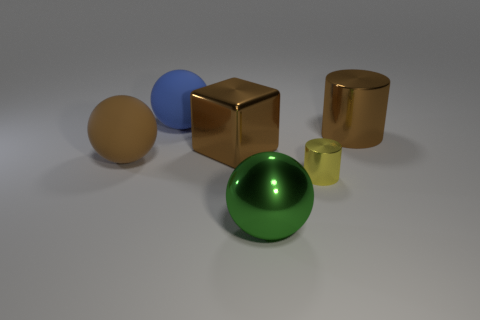Are there any other large shiny objects that have the same shape as the large green shiny thing?
Make the answer very short. No. Is the number of large matte things less than the number of big green rubber cylinders?
Provide a succinct answer. No. There is a shiny ball that is to the right of the large brown ball; what color is it?
Give a very brief answer. Green. There is a matte thing that is left of the big sphere behind the brown cube; what shape is it?
Your answer should be very brief. Sphere. Is the blue sphere made of the same material as the sphere that is to the right of the large block?
Offer a terse response. No. There is a metallic object that is the same color as the shiny cube; what is its shape?
Your answer should be very brief. Cylinder. What number of green metallic spheres have the same size as the blue matte thing?
Give a very brief answer. 1. Are there fewer large brown objects to the left of the blue matte object than big red rubber balls?
Give a very brief answer. No. What number of yellow objects are to the left of the tiny yellow metal thing?
Make the answer very short. 0. There is a cylinder that is in front of the matte ball that is in front of the big brown shiny thing right of the yellow metallic thing; what size is it?
Give a very brief answer. Small. 